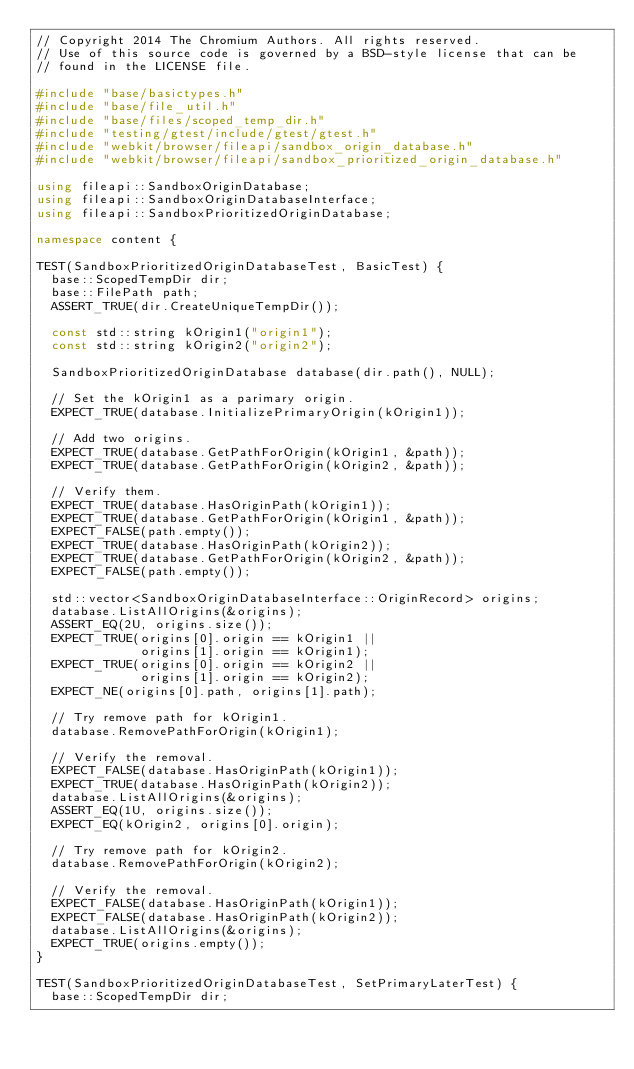Convert code to text. <code><loc_0><loc_0><loc_500><loc_500><_C++_>// Copyright 2014 The Chromium Authors. All rights reserved.
// Use of this source code is governed by a BSD-style license that can be
// found in the LICENSE file.

#include "base/basictypes.h"
#include "base/file_util.h"
#include "base/files/scoped_temp_dir.h"
#include "testing/gtest/include/gtest/gtest.h"
#include "webkit/browser/fileapi/sandbox_origin_database.h"
#include "webkit/browser/fileapi/sandbox_prioritized_origin_database.h"

using fileapi::SandboxOriginDatabase;
using fileapi::SandboxOriginDatabaseInterface;
using fileapi::SandboxPrioritizedOriginDatabase;

namespace content {

TEST(SandboxPrioritizedOriginDatabaseTest, BasicTest) {
  base::ScopedTempDir dir;
  base::FilePath path;
  ASSERT_TRUE(dir.CreateUniqueTempDir());

  const std::string kOrigin1("origin1");
  const std::string kOrigin2("origin2");

  SandboxPrioritizedOriginDatabase database(dir.path(), NULL);

  // Set the kOrigin1 as a parimary origin.
  EXPECT_TRUE(database.InitializePrimaryOrigin(kOrigin1));

  // Add two origins.
  EXPECT_TRUE(database.GetPathForOrigin(kOrigin1, &path));
  EXPECT_TRUE(database.GetPathForOrigin(kOrigin2, &path));

  // Verify them.
  EXPECT_TRUE(database.HasOriginPath(kOrigin1));
  EXPECT_TRUE(database.GetPathForOrigin(kOrigin1, &path));
  EXPECT_FALSE(path.empty());
  EXPECT_TRUE(database.HasOriginPath(kOrigin2));
  EXPECT_TRUE(database.GetPathForOrigin(kOrigin2, &path));
  EXPECT_FALSE(path.empty());

  std::vector<SandboxOriginDatabaseInterface::OriginRecord> origins;
  database.ListAllOrigins(&origins);
  ASSERT_EQ(2U, origins.size());
  EXPECT_TRUE(origins[0].origin == kOrigin1 ||
              origins[1].origin == kOrigin1);
  EXPECT_TRUE(origins[0].origin == kOrigin2 ||
              origins[1].origin == kOrigin2);
  EXPECT_NE(origins[0].path, origins[1].path);

  // Try remove path for kOrigin1.
  database.RemovePathForOrigin(kOrigin1);

  // Verify the removal.
  EXPECT_FALSE(database.HasOriginPath(kOrigin1));
  EXPECT_TRUE(database.HasOriginPath(kOrigin2));
  database.ListAllOrigins(&origins);
  ASSERT_EQ(1U, origins.size());
  EXPECT_EQ(kOrigin2, origins[0].origin);

  // Try remove path for kOrigin2.
  database.RemovePathForOrigin(kOrigin2);

  // Verify the removal.
  EXPECT_FALSE(database.HasOriginPath(kOrigin1));
  EXPECT_FALSE(database.HasOriginPath(kOrigin2));
  database.ListAllOrigins(&origins);
  EXPECT_TRUE(origins.empty());
}

TEST(SandboxPrioritizedOriginDatabaseTest, SetPrimaryLaterTest) {
  base::ScopedTempDir dir;</code> 